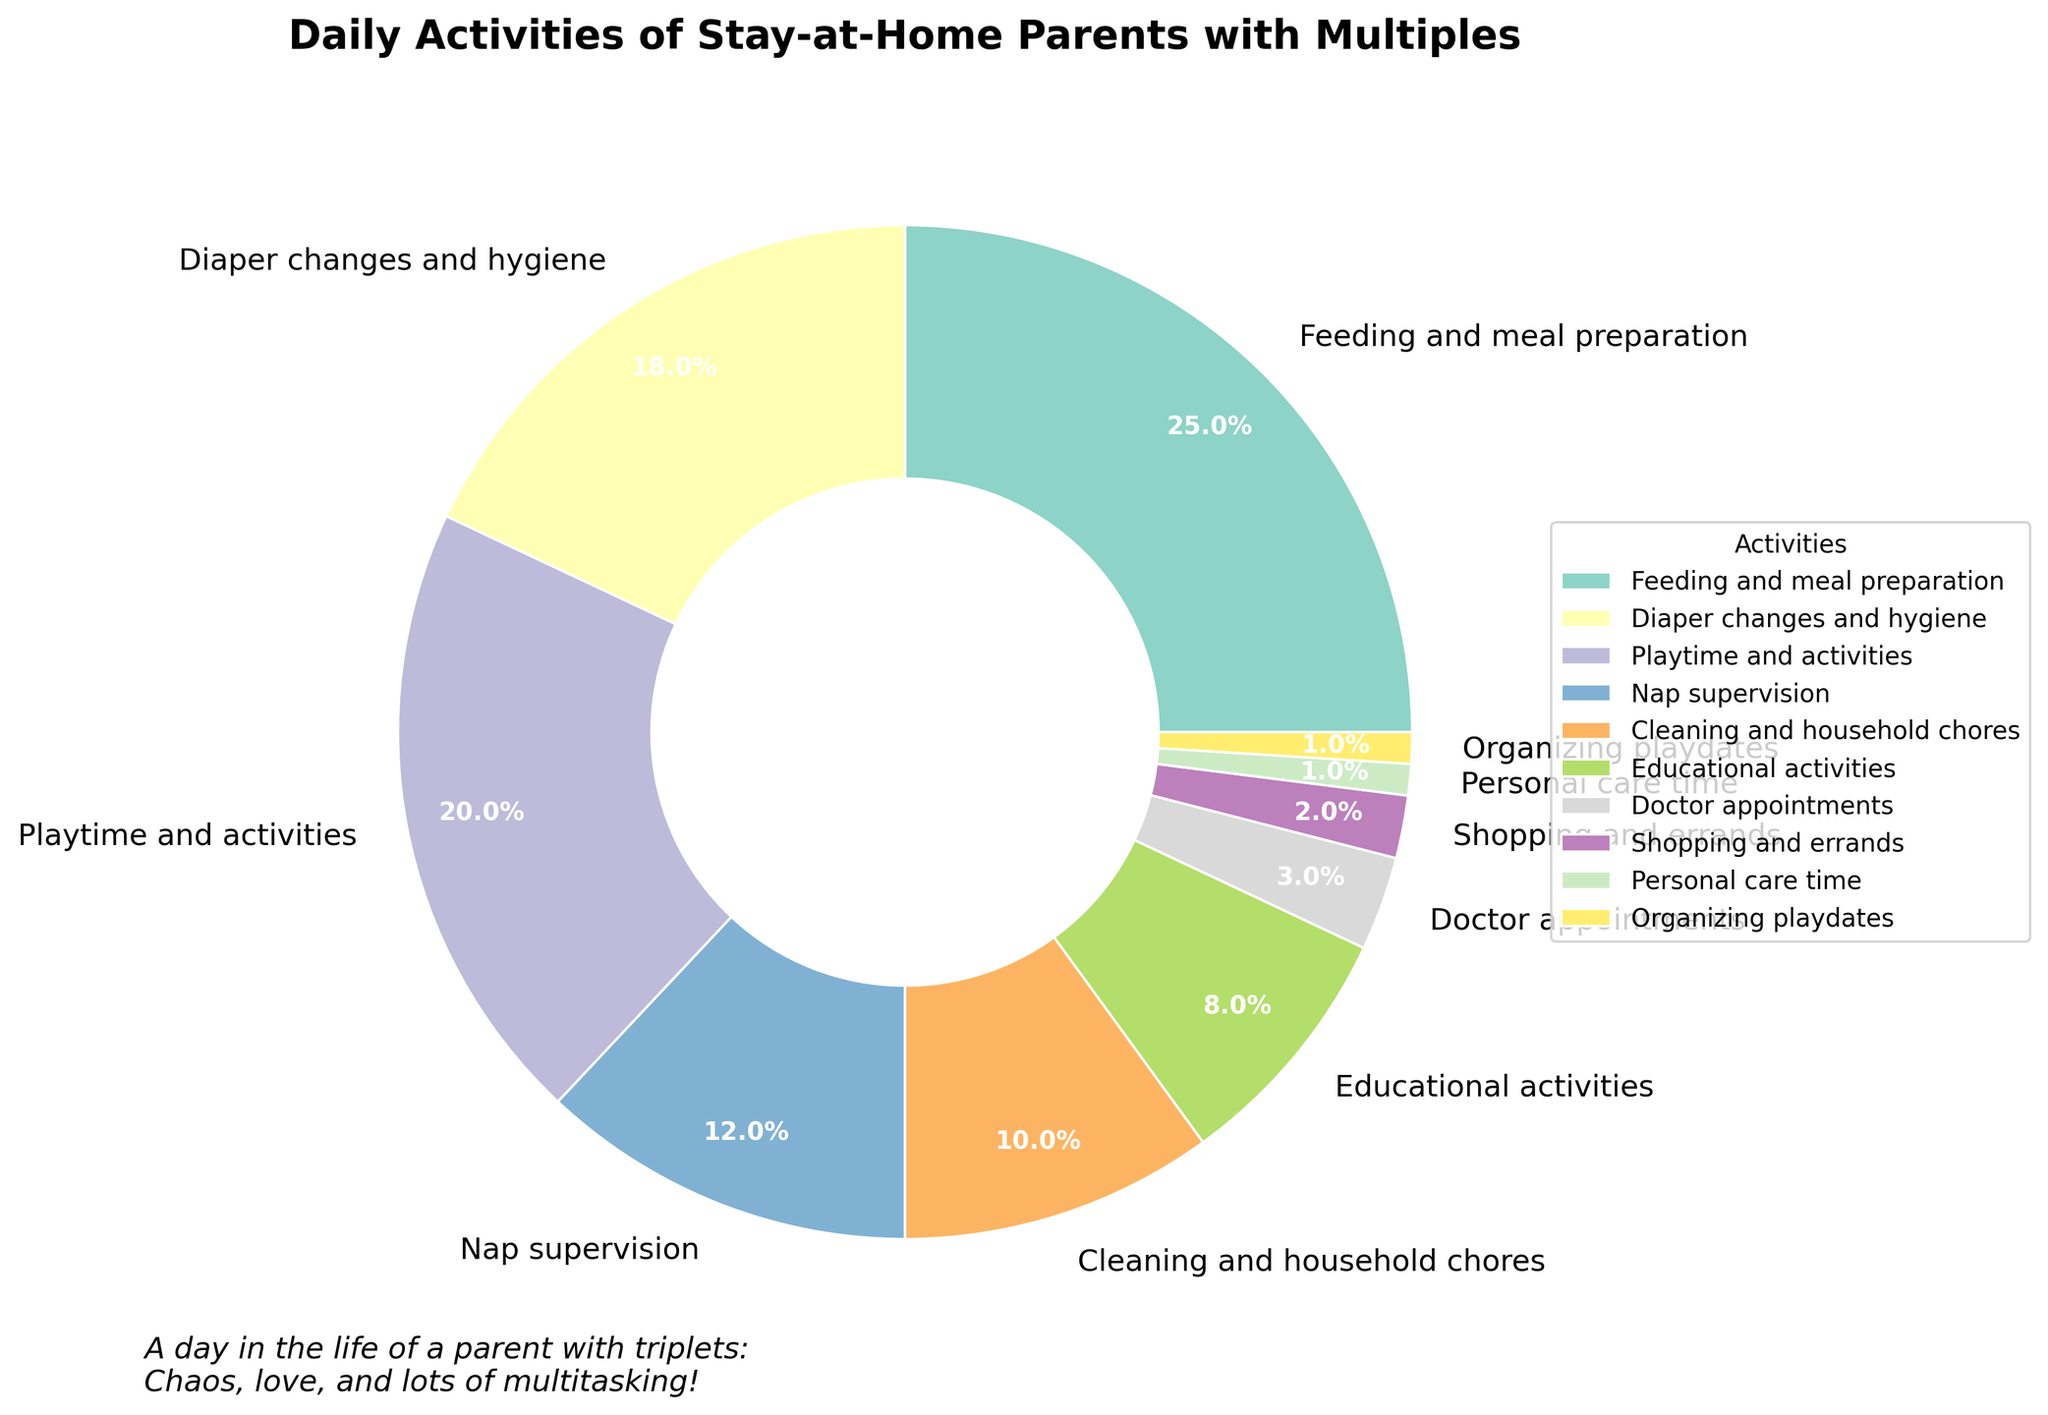Which activity takes the largest percentage of time for stay-at-home parents with multiples? The activity with the largest wedge in the pie chart represents the highest percentage. In this case, "Feeding and meal preparation" has the largest percentage at 25%.
Answer: Feeding and meal preparation Which activity takes up the least amount of time in a day? The smallest wedge in the pie chart represents the smallest percentage. "Personal care time" and "Organizing playdates" both have the smallest percentage at 1% each.
Answer: Personal care time and Organizing playdates What is the combined percentage of time spent on "Feeding and meal preparation" and "Diaper changes and hygiene"? Add the percentages for "Feeding and meal preparation" (25%) and "Diaper changes and hygiene" (18%): 25 + 18 = 43
Answer: 43% How does the time spent on "Playtime and activities" compare to the time spent on "Cleaning and household chores"? The percentage for "Playtime and activities" (20%) is higher than the percentage for "Cleaning and household chores" (10%).
Answer: Playtime and activities What percentage of time is spent on activities related to children's health including "Doctor appointments"? Look for percentages related to children's health: "Diaper changes and hygiene" (18%) and "Doctor appointments" (3%). Add these together: 18 + 3 = 21
Answer: 21% How does the percentage of "Educational activities" compare to "Nap supervision"? The percentage for "Educational activities" (8%) is lower than the percentage for "Nap supervision" (12%).
Answer: Nap supervision is higher What is the total percentage of time allotted for tasks not directly involving the children (excluding "Feeding and meal preparation", "Diaper changes and hygiene", "Playtime and activities", "Nap supervision", and "Educational activities")? Summing all other activities: "Cleaning and household chores" (10%), "Doctor appointments" (3%), "Shopping and errands" (2%), "Personal care time" (1%), "Organizing playdates" (1%): 10 + 3 + 2 + 1 + 1 = 17
Answer: 17% Among the activities listed, which takes up exactly 10% of the daily time? Locate the wedge labeled with exactly 10%. In this case, it's "Cleaning and household chores".
Answer: Cleaning and household chores Between "Doctor appointments" and "Shopping and errands," which activity takes more time? Compare the wedges for these two activities. "Doctor appointments" takes 3%, while "Shopping and errands" takes 2%.
Answer: Doctor appointments How much more time is spent on "Playtime and activities" compared to the combination of "Doctor appointments" and "Shopping and errands"? Add the percentages for "Doctor appointments" (3%) and "Shopping and errands" (2%): 3 + 2 = 5. Then subtract this from "Playtime and activities" (20%): 20 - 5 = 15
Answer: 15% 